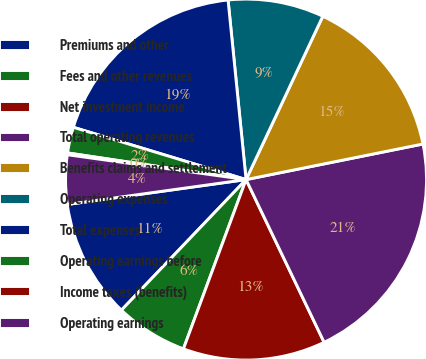Convert chart to OTSL. <chart><loc_0><loc_0><loc_500><loc_500><pie_chart><fcel>Premiums and other<fcel>Fees and other revenues<fcel>Net investment income<fcel>Total operating revenues<fcel>Benefits claims and settlement<fcel>Operating expenses<fcel>Total expenses<fcel>Operating earnings before<fcel>Income taxes (benefits)<fcel>Operating earnings<nl><fcel>10.67%<fcel>6.49%<fcel>12.76%<fcel>21.04%<fcel>14.85%<fcel>8.58%<fcel>18.73%<fcel>2.32%<fcel>0.16%<fcel>4.4%<nl></chart> 